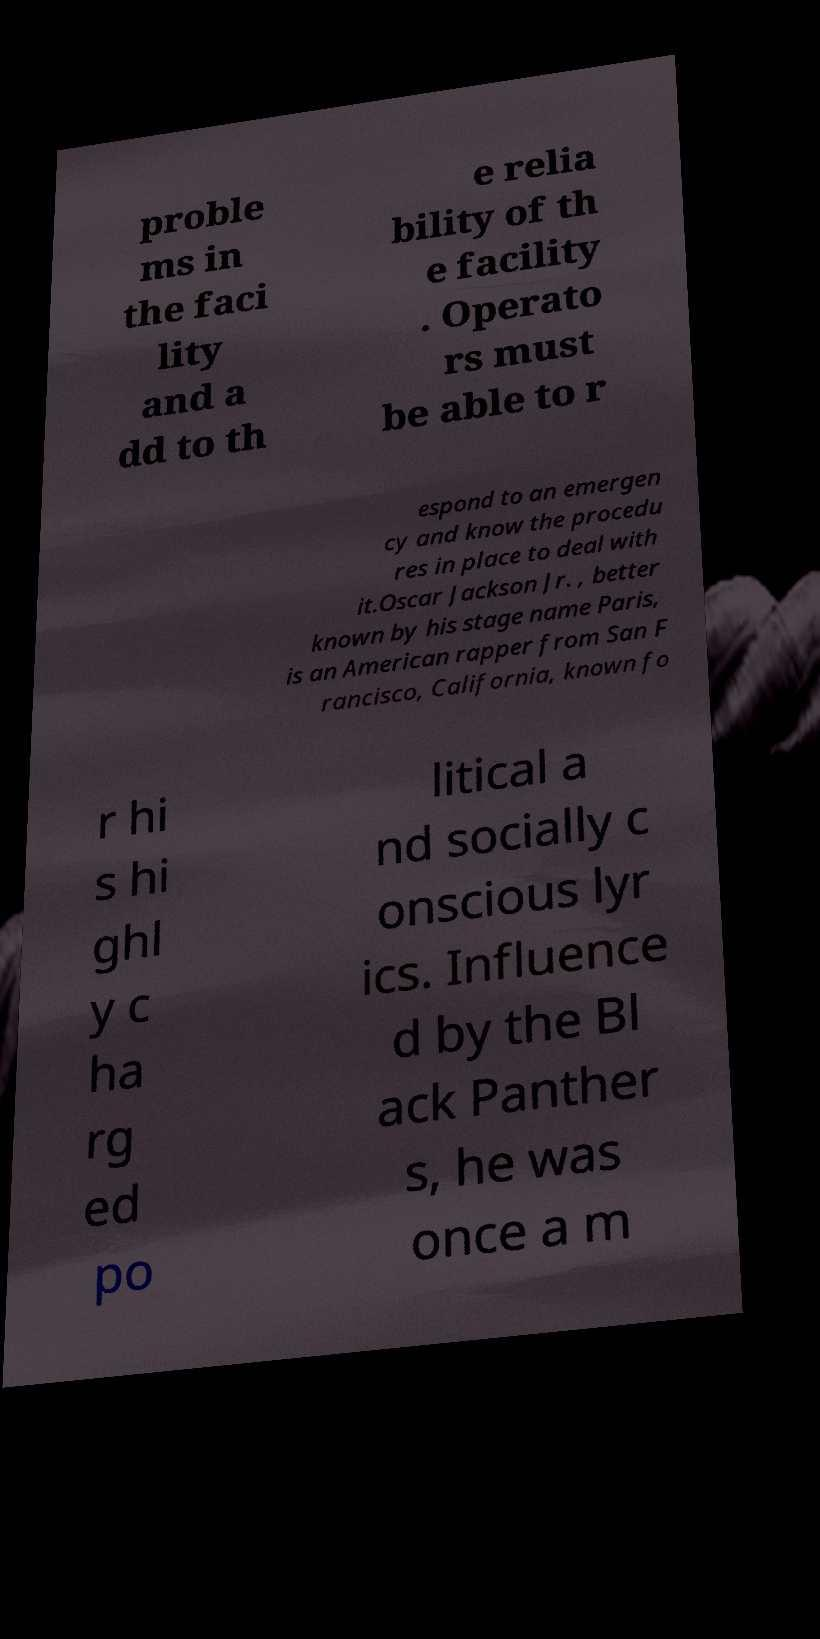What messages or text are displayed in this image? I need them in a readable, typed format. proble ms in the faci lity and a dd to th e relia bility of th e facility . Operato rs must be able to r espond to an emergen cy and know the procedu res in place to deal with it.Oscar Jackson Jr. , better known by his stage name Paris, is an American rapper from San F rancisco, California, known fo r hi s hi ghl y c ha rg ed po litical a nd socially c onscious lyr ics. Influence d by the Bl ack Panther s, he was once a m 